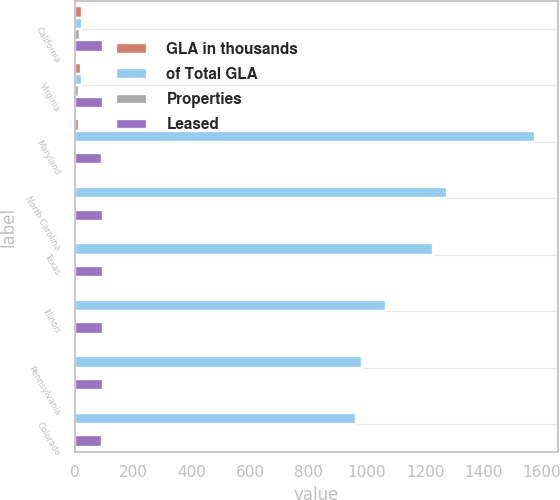Convert chart. <chart><loc_0><loc_0><loc_500><loc_500><stacked_bar_chart><ecel><fcel>California<fcel>Virginia<fcel>Maryland<fcel>North Carolina<fcel>Texas<fcel>Illinois<fcel>Pennsylvania<fcel>Colorado<nl><fcel>GLA in thousands<fcel>25<fcel>22<fcel>14<fcel>8<fcel>9<fcel>8<fcel>7<fcel>6<nl><fcel>of Total GLA<fcel>23.5<fcel>23.5<fcel>1577<fcel>1276<fcel>1227<fcel>1067<fcel>982<fcel>962<nl><fcel>Properties<fcel>18.4<fcel>15.7<fcel>8.9<fcel>7.2<fcel>6.9<fcel>6<fcel>5.5<fcel>5.4<nl><fcel>Leased<fcel>95.7<fcel>96.3<fcel>92.9<fcel>96.4<fcel>95.9<fcel>97.1<fcel>96.1<fcel>93<nl></chart> 